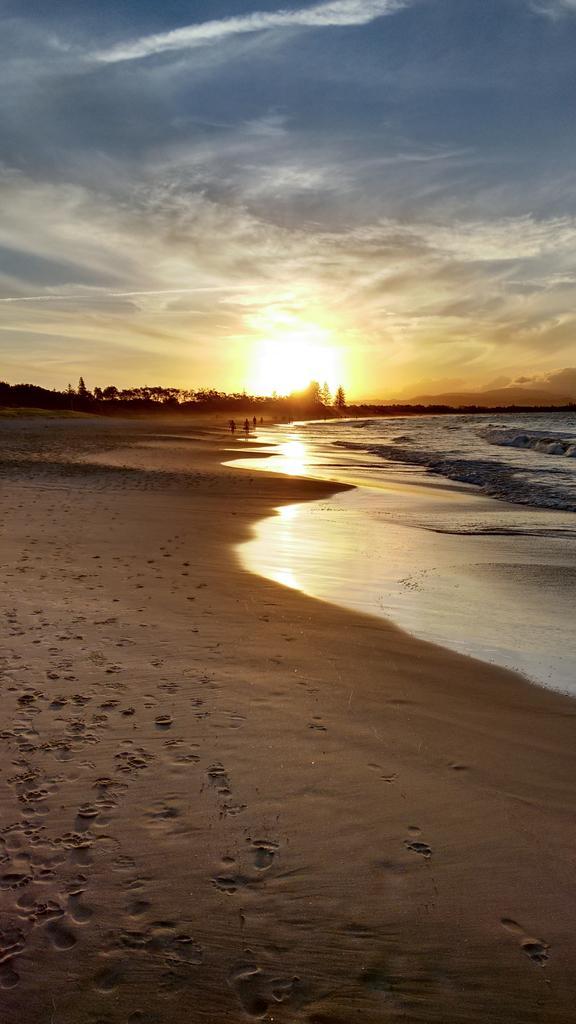Could you give a brief overview of what you see in this image? In this image there is the sky truncated towards the top of the image, there are clouds in the sky, there is sun in the sky, there is water truncated towards the right of the image, there are trees truncated towards the left of the image, there is sand truncated towards the left of the image, there is sand truncated towards the bottom of the image, there is sand truncated towards the right of the image. 